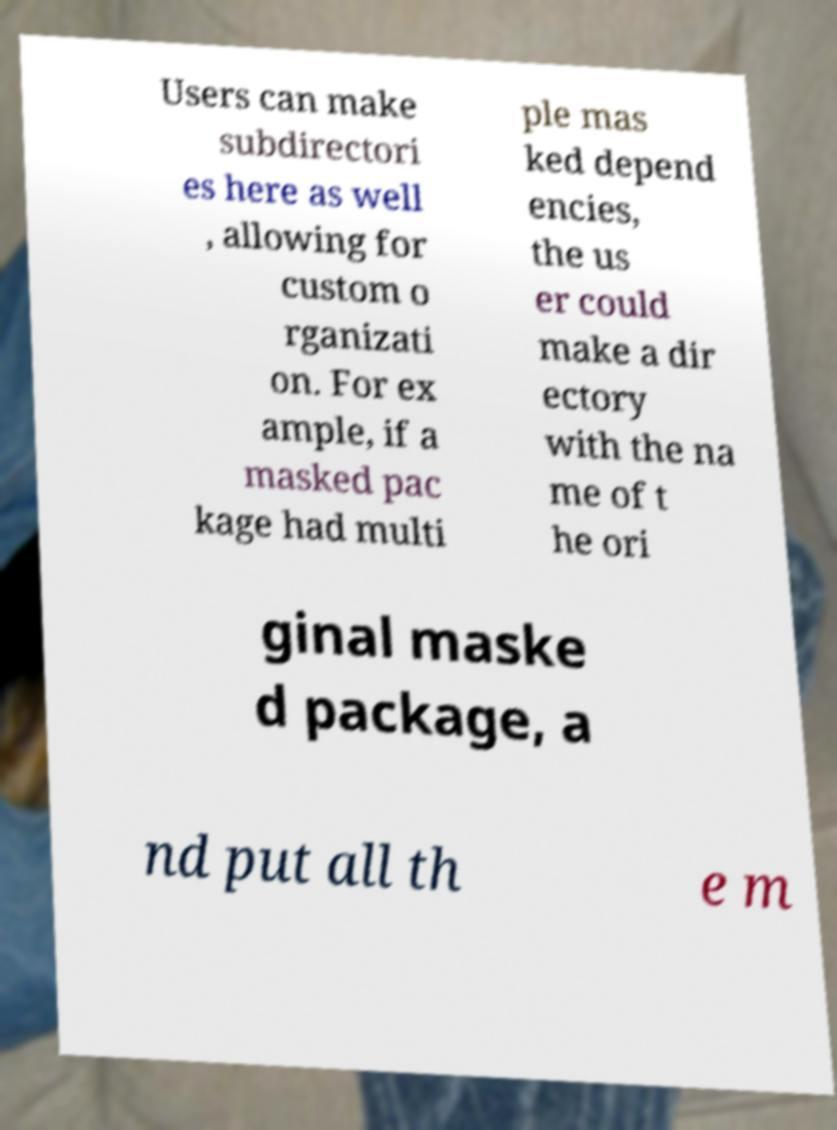I need the written content from this picture converted into text. Can you do that? Users can make subdirectori es here as well , allowing for custom o rganizati on. For ex ample, if a masked pac kage had multi ple mas ked depend encies, the us er could make a dir ectory with the na me of t he ori ginal maske d package, a nd put all th e m 